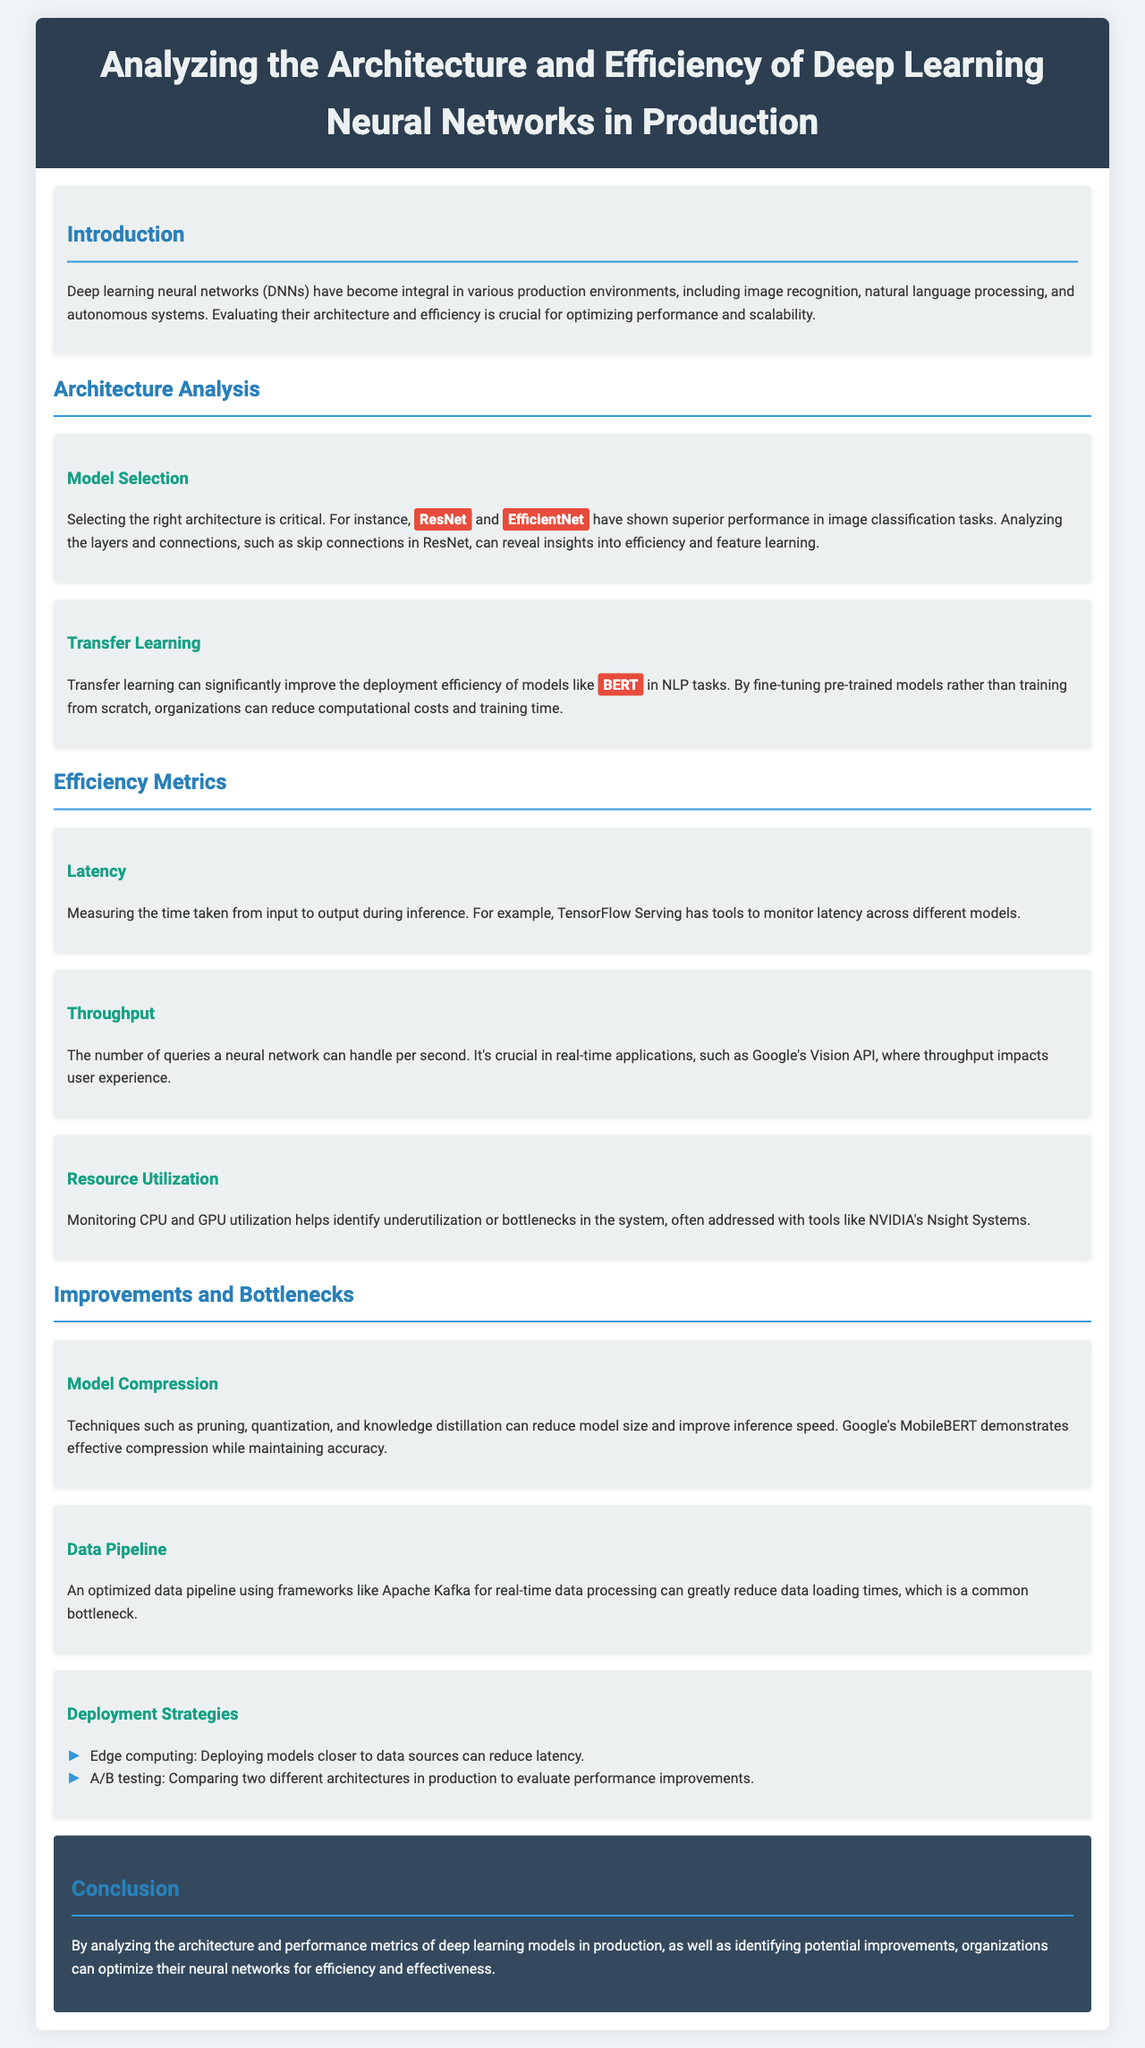what is the title of the document? The title is presented in the header section of the document, which states "Analyzing the Architecture and Efficiency of Deep Learning Neural Networks in Production."
Answer: Analyzing the Architecture and Efficiency of Deep Learning Neural Networks in Production which two models are mentioned as superior for image classification? The document lists specific models under the "Model Selection" section, highlighting "ResNet" and "EfficientNet" as superior in performance.
Answer: ResNet, EfficientNet what is a benefit of transfer learning mentioned in the report? The report states that transfer learning can significantly improve deployment efficiency for models like "BERT," indicating reduced computational costs and training time.
Answer: Reduced computational costs what is measured to determine latency? The document explains that latency is measured by the time taken from input to output during inference.
Answer: Time from input to output which technique can reduce model size? In the "Model Compression" section, the document mentions techniques like "pruning," "quantization," and "knowledge distillation" for reducing model size.
Answer: Pruning which deployment strategy can reduce latency? The document discusses a particular deployment strategy that mentions "Edge computing," which refers to deploying models closer to data sources.
Answer: Edge computing what is the main objective of this analysis report? The conclusion section summarizes the main objective, which is to optimize neural networks for efficiency and effectiveness by analyzing their architecture and performance metrics.
Answer: Optimize neural networks what tool can monitor latency across different models? The document refers to "TensorFlow Serving" as a tool for monitoring latency.
Answer: TensorFlow Serving what is a common bottleneck addressed in the report? The report highlights "data loading times" as a common bottleneck that can be addressed through an optimized data pipeline.
Answer: Data loading times 